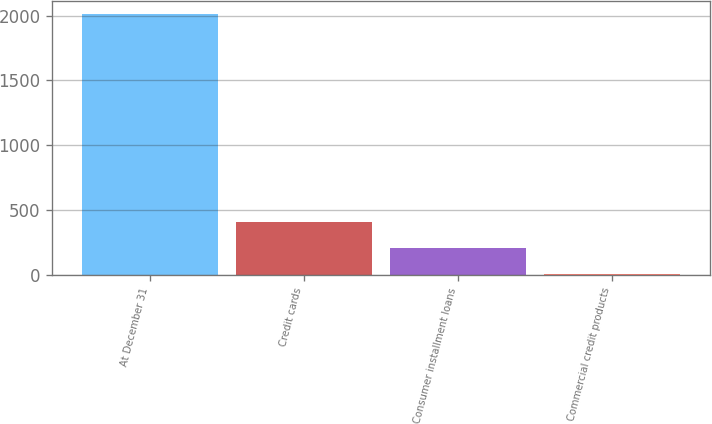Convert chart. <chart><loc_0><loc_0><loc_500><loc_500><bar_chart><fcel>At December 31<fcel>Credit cards<fcel>Consumer installment loans<fcel>Commercial credit products<nl><fcel>2015<fcel>406.6<fcel>205.55<fcel>4.5<nl></chart> 